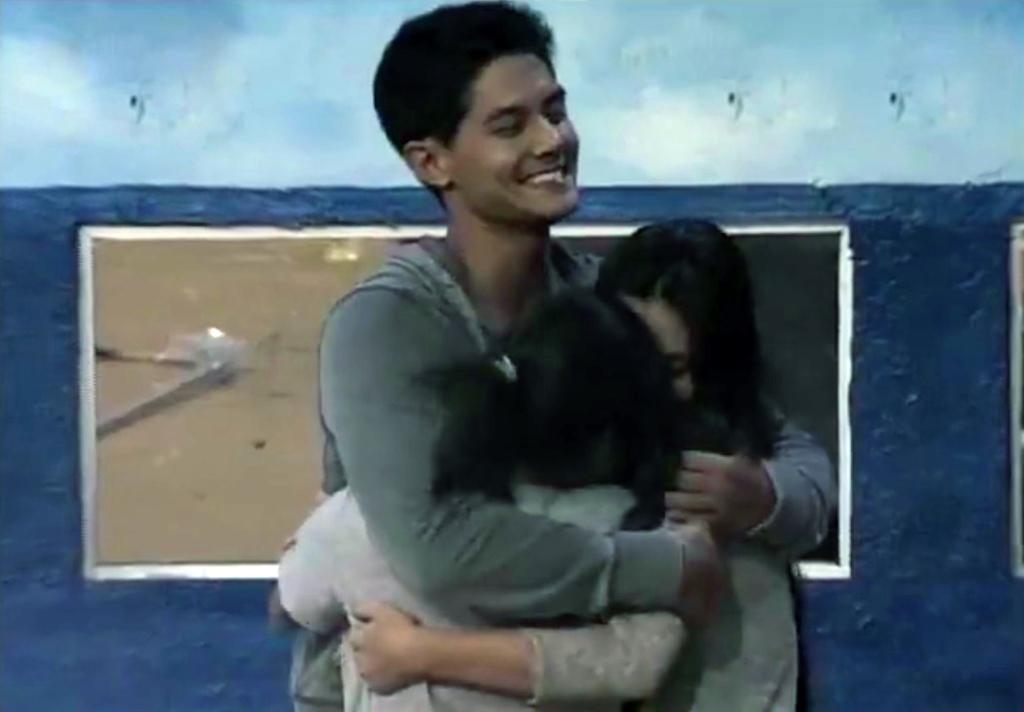How many people are in the image? There are three persons in the image. What are the three persons doing? The three persons are hugging each other. What can be seen in the background of the image? There is a wall in the background of the image. Is there anything attached to the wall? Yes, a photo frame is attached to the wall. How does the person in the middle of the image balance a unicycle while hugging the other two persons? There is no unicycle present in the image, and the persons are not balancing any objects while hugging each other. 